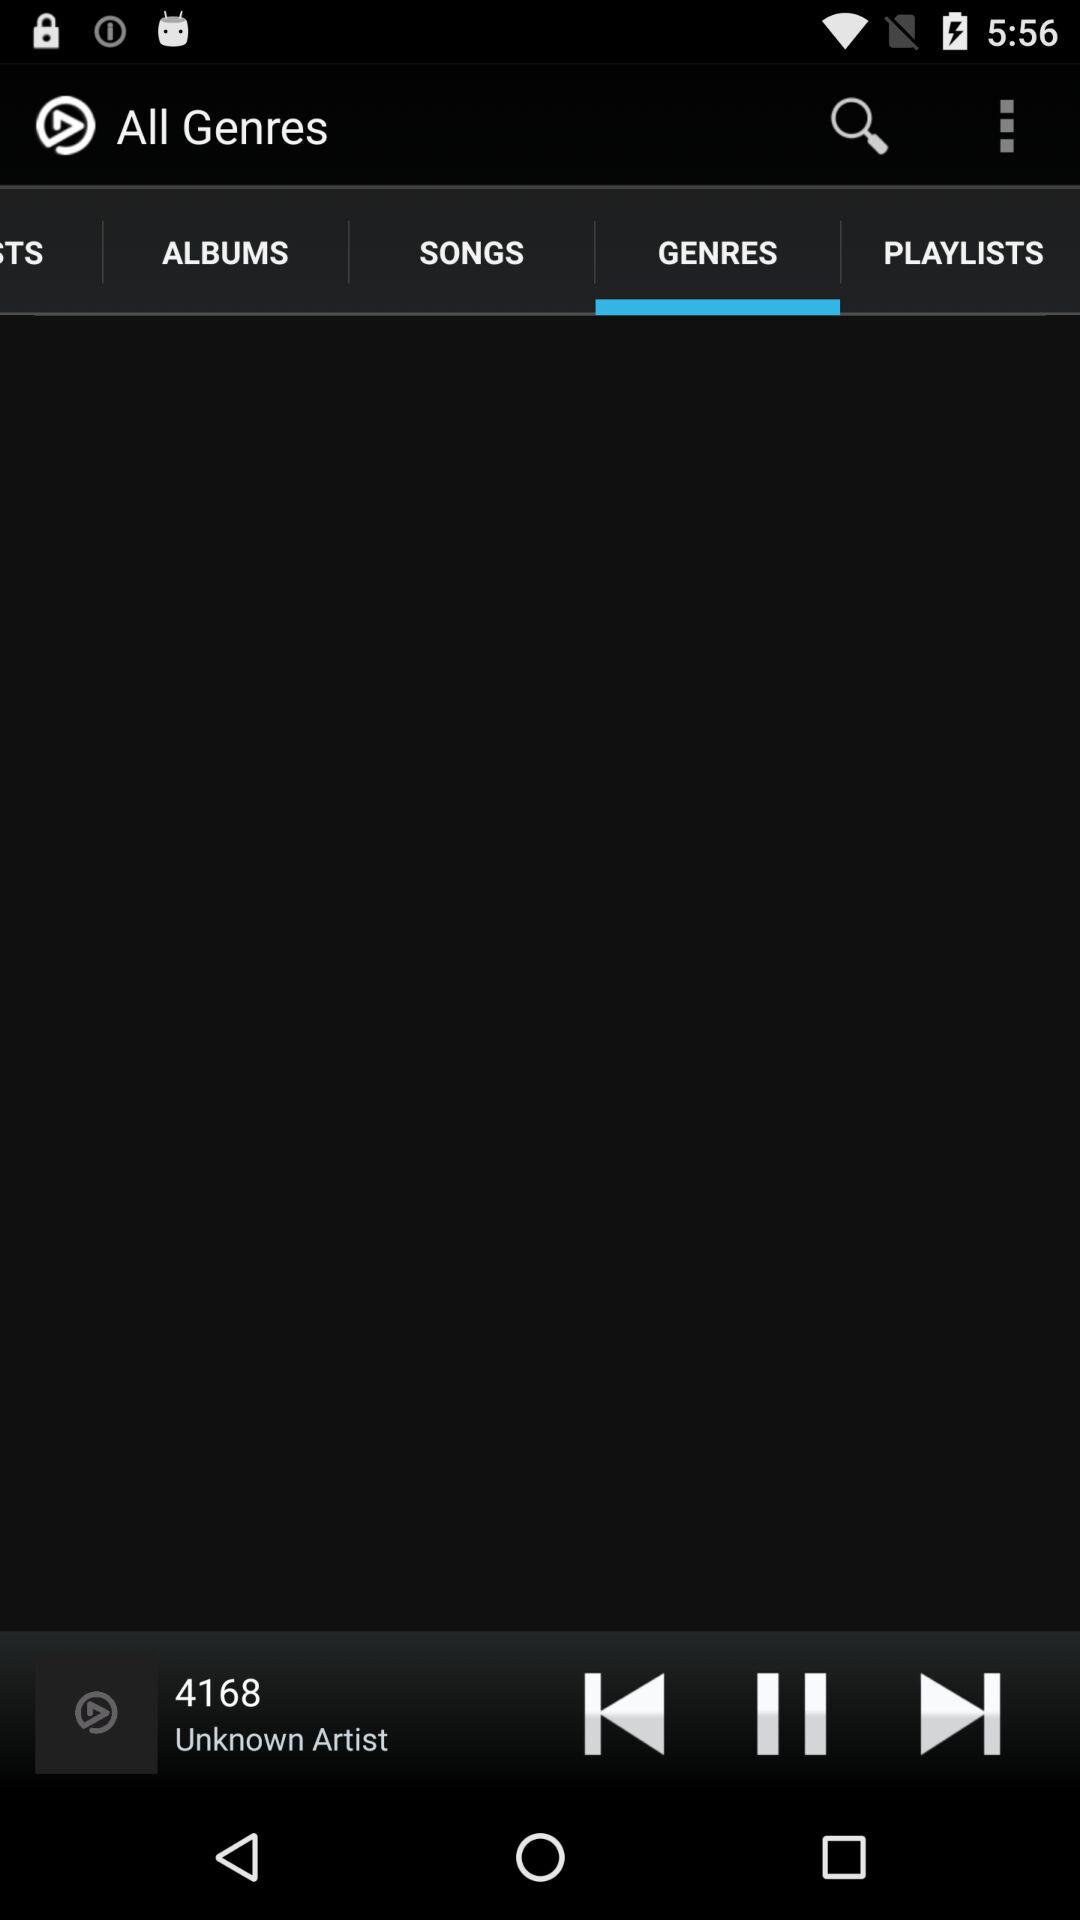Which tab am I on? You are on the "GENRES" tab. 